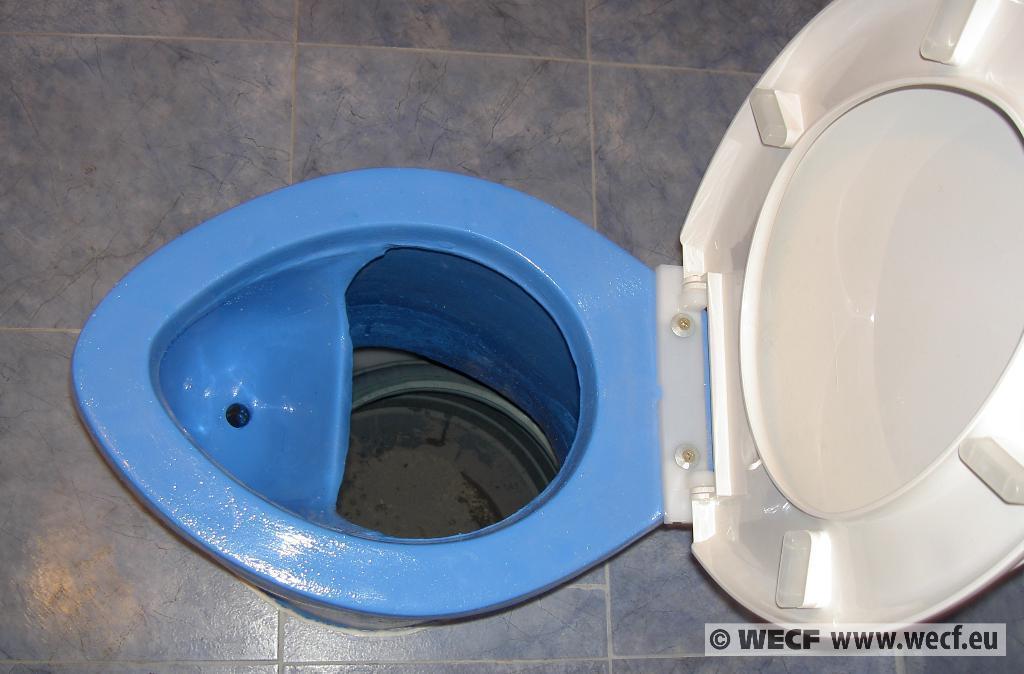How would you summarize this image in a sentence or two? In this image, I can see a toilet seat with a toilet lid. In the background, I can see the floor. At the bottom of the image, that looks like the watermark. 